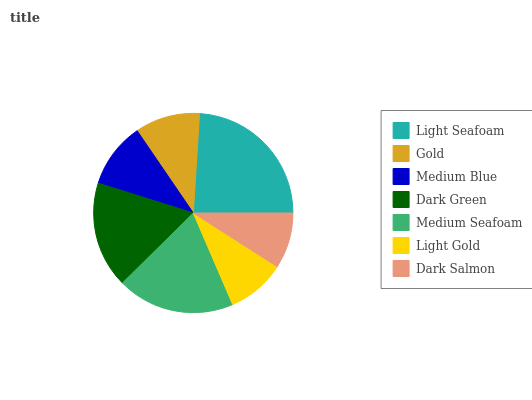Is Dark Salmon the minimum?
Answer yes or no. Yes. Is Light Seafoam the maximum?
Answer yes or no. Yes. Is Gold the minimum?
Answer yes or no. No. Is Gold the maximum?
Answer yes or no. No. Is Light Seafoam greater than Gold?
Answer yes or no. Yes. Is Gold less than Light Seafoam?
Answer yes or no. Yes. Is Gold greater than Light Seafoam?
Answer yes or no. No. Is Light Seafoam less than Gold?
Answer yes or no. No. Is Medium Blue the high median?
Answer yes or no. Yes. Is Medium Blue the low median?
Answer yes or no. Yes. Is Gold the high median?
Answer yes or no. No. Is Medium Seafoam the low median?
Answer yes or no. No. 